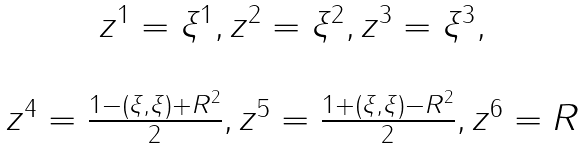Convert formula to latex. <formula><loc_0><loc_0><loc_500><loc_500>\begin{array} { c } z ^ { 1 } = \xi ^ { 1 } , z ^ { 2 } = \xi ^ { 2 } , z ^ { 3 } = \xi ^ { 3 } , \\ \ \\ z ^ { 4 } = \frac { 1 - ( { \xi } , { \xi } ) + R ^ { 2 } } { 2 } , z ^ { 5 } = \frac { 1 + ( { \xi } , { \xi } ) - R ^ { 2 } } { 2 } , z ^ { 6 } = R \end{array}</formula> 